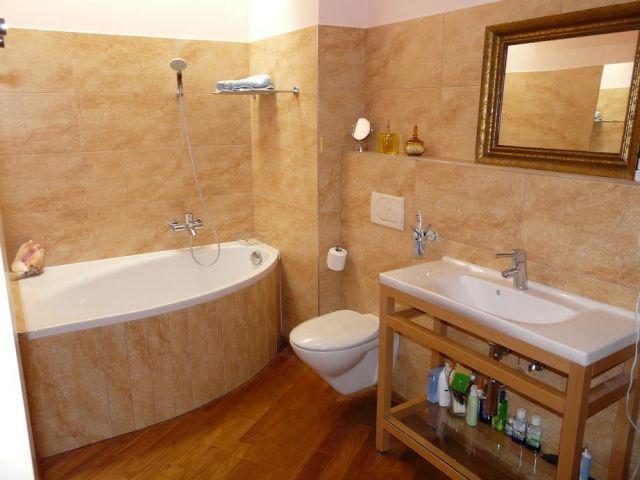Is the tile in the shower the same size as the tile on the wall outside the shower?
Quick response, please. Yes. Where is the shower curtain?
Quick response, please. No. Is the water on?
Short answer required. No. Is this room clean?
Be succinct. Yes. 